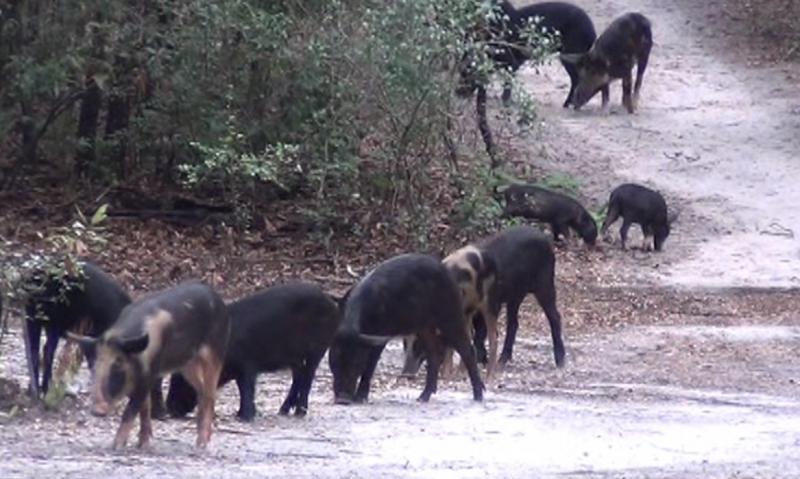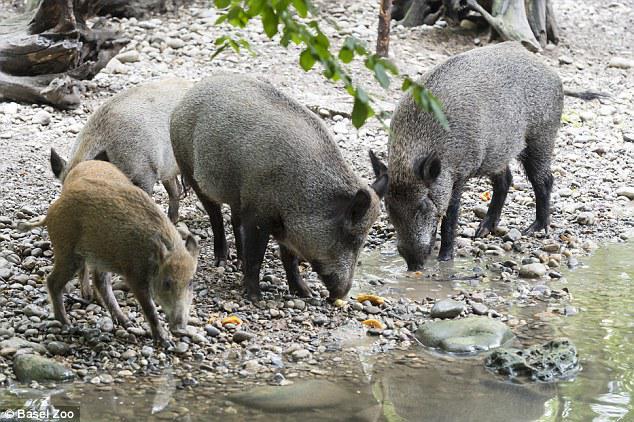The first image is the image on the left, the second image is the image on the right. Given the left and right images, does the statement "At least one of the images shows exactly one boar." hold true? Answer yes or no. No. The first image is the image on the left, the second image is the image on the right. Given the left and right images, does the statement "there is exactly one boar in the image on the right" hold true? Answer yes or no. No. 